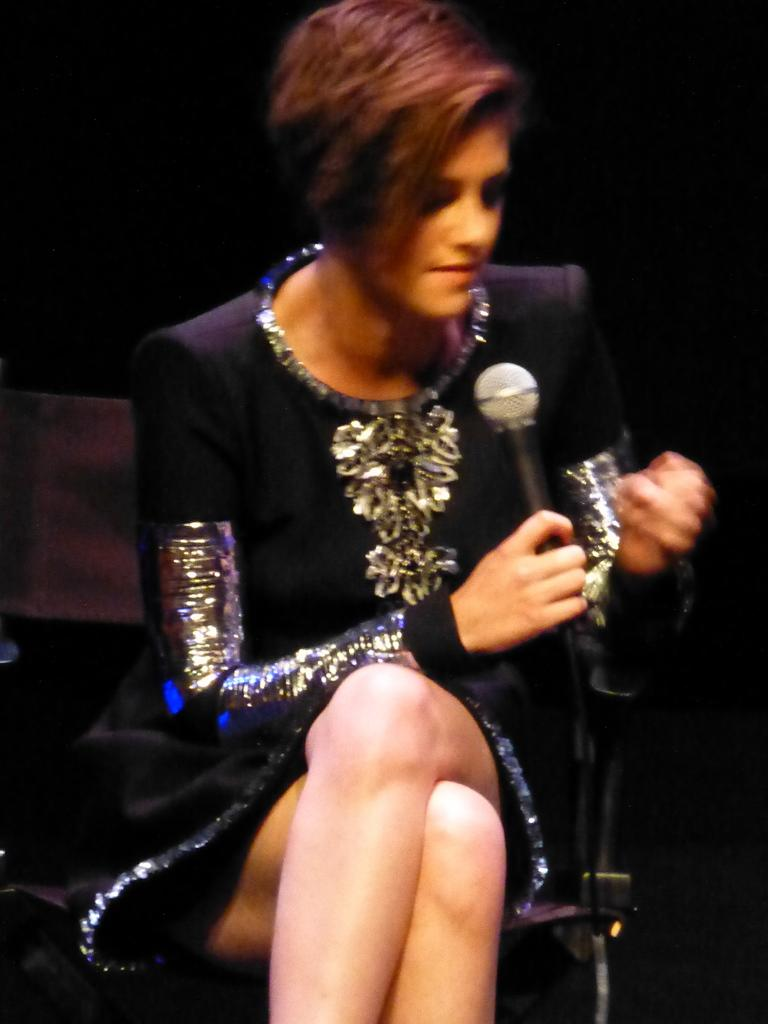Who is the main subject in the image? There is a woman in the image. What is the woman doing in the image? The woman is sitting on a chair. What is the woman wearing in the image? The woman is wearing a black and silver dress. What object is the woman holding in the image? The woman is holding a mic. What color is the background of the image? The background of the image is black. What type of prison can be seen in the background of the image? There is no prison present in the image; the background is black. How many feet are visible in the image? There are no feet visible in the image; it only shows a woman sitting on a chair. 